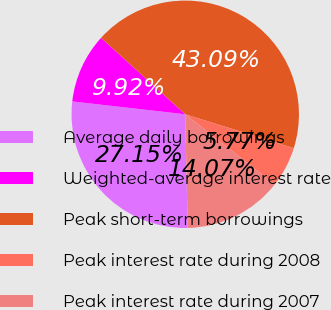Convert chart to OTSL. <chart><loc_0><loc_0><loc_500><loc_500><pie_chart><fcel>Average daily borrowings<fcel>Weighted-average interest rate<fcel>Peak short-term borrowings<fcel>Peak interest rate during 2008<fcel>Peak interest rate during 2007<nl><fcel>27.15%<fcel>9.92%<fcel>43.09%<fcel>5.77%<fcel>14.07%<nl></chart> 